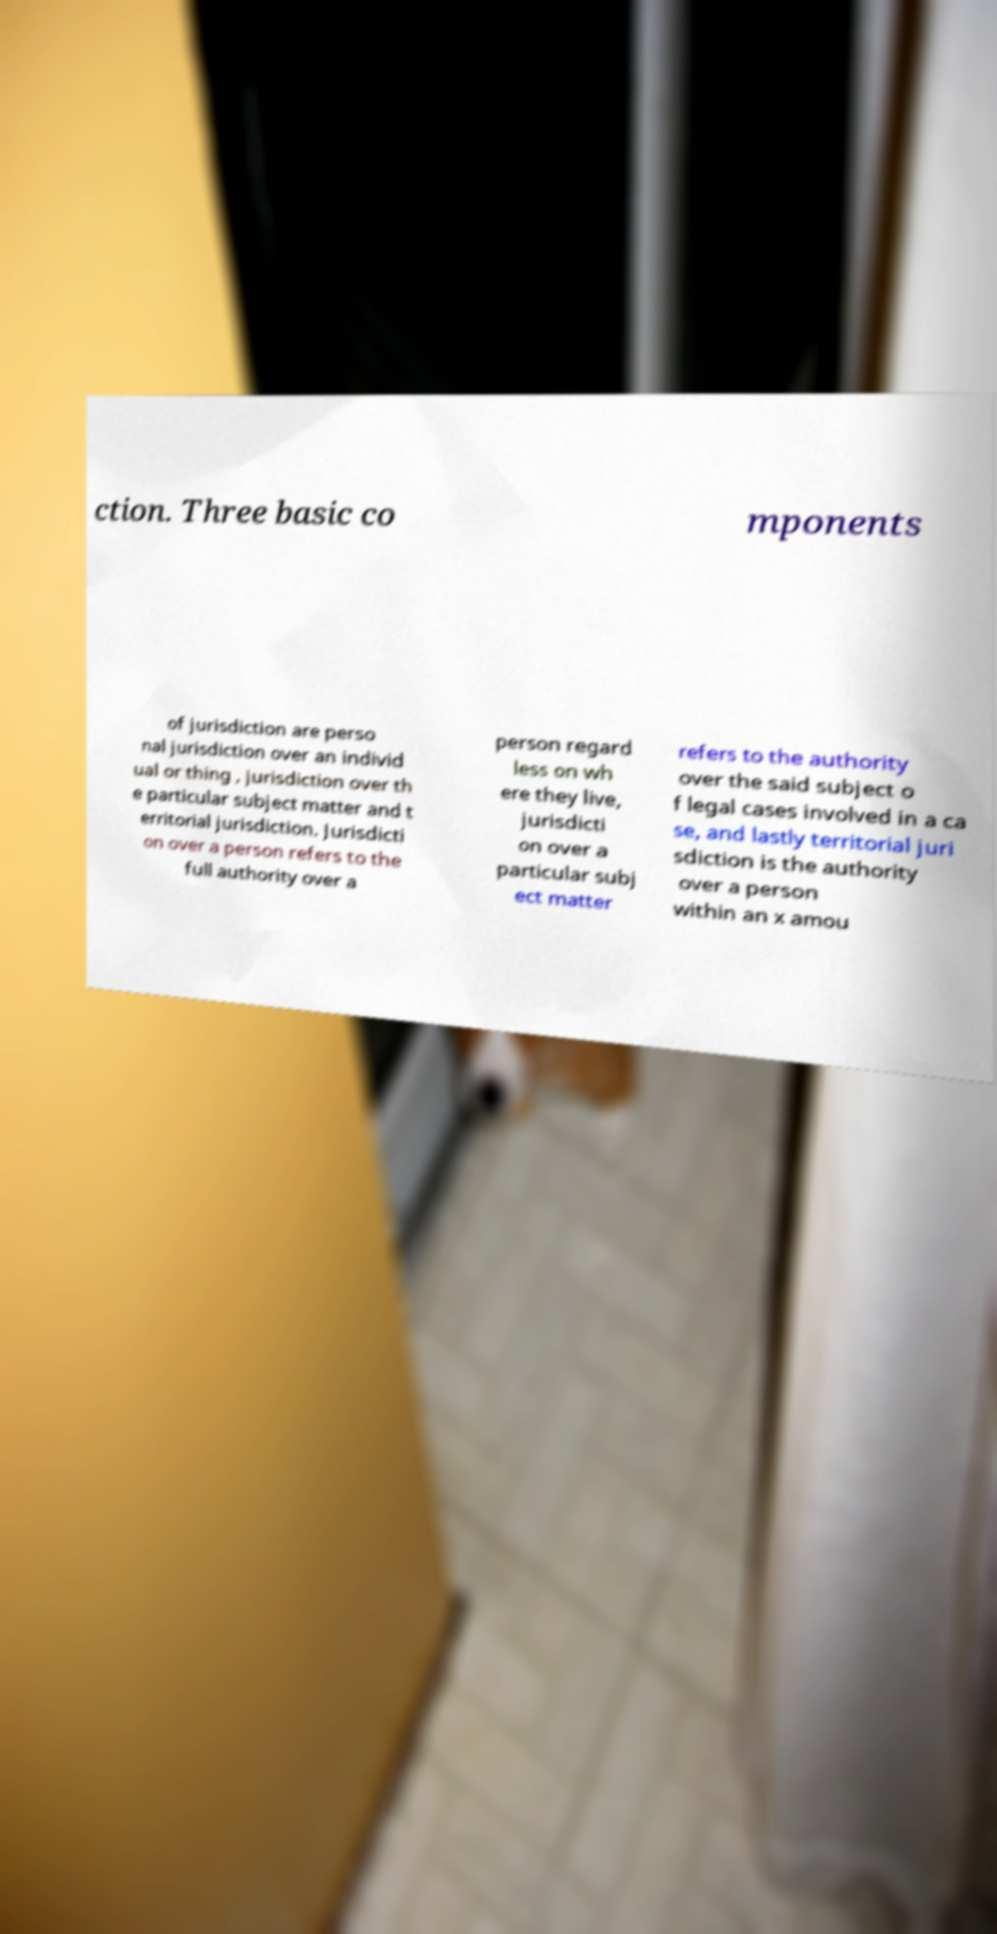Could you extract and type out the text from this image? ction. Three basic co mponents of jurisdiction are perso nal jurisdiction over an individ ual or thing , jurisdiction over th e particular subject matter and t erritorial jurisdiction. Jurisdicti on over a person refers to the full authority over a person regard less on wh ere they live, jurisdicti on over a particular subj ect matter refers to the authority over the said subject o f legal cases involved in a ca se, and lastly territorial juri sdiction is the authority over a person within an x amou 